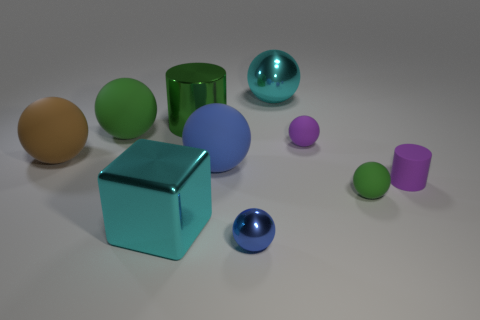Do the cyan metal thing that is behind the brown thing and the purple matte ball have the same size?
Your answer should be very brief. No. Are there any red metal cylinders of the same size as the blue matte ball?
Your answer should be very brief. No. What is the color of the shiny thing that is to the right of the tiny blue object?
Your answer should be very brief. Cyan. What shape is the thing that is both behind the large green sphere and right of the small blue ball?
Provide a short and direct response. Sphere. What number of tiny green rubber objects are the same shape as the big brown rubber thing?
Ensure brevity in your answer.  1. What number of small matte cylinders are there?
Offer a terse response. 1. How big is the ball that is right of the big shiny ball and in front of the brown rubber sphere?
Make the answer very short. Small. There is a brown matte object that is the same size as the blue matte object; what is its shape?
Offer a terse response. Sphere. There is a blue thing right of the blue rubber ball; are there any small spheres behind it?
Give a very brief answer. Yes. There is a big metallic object that is the same shape as the large blue rubber thing; what is its color?
Offer a very short reply. Cyan. 